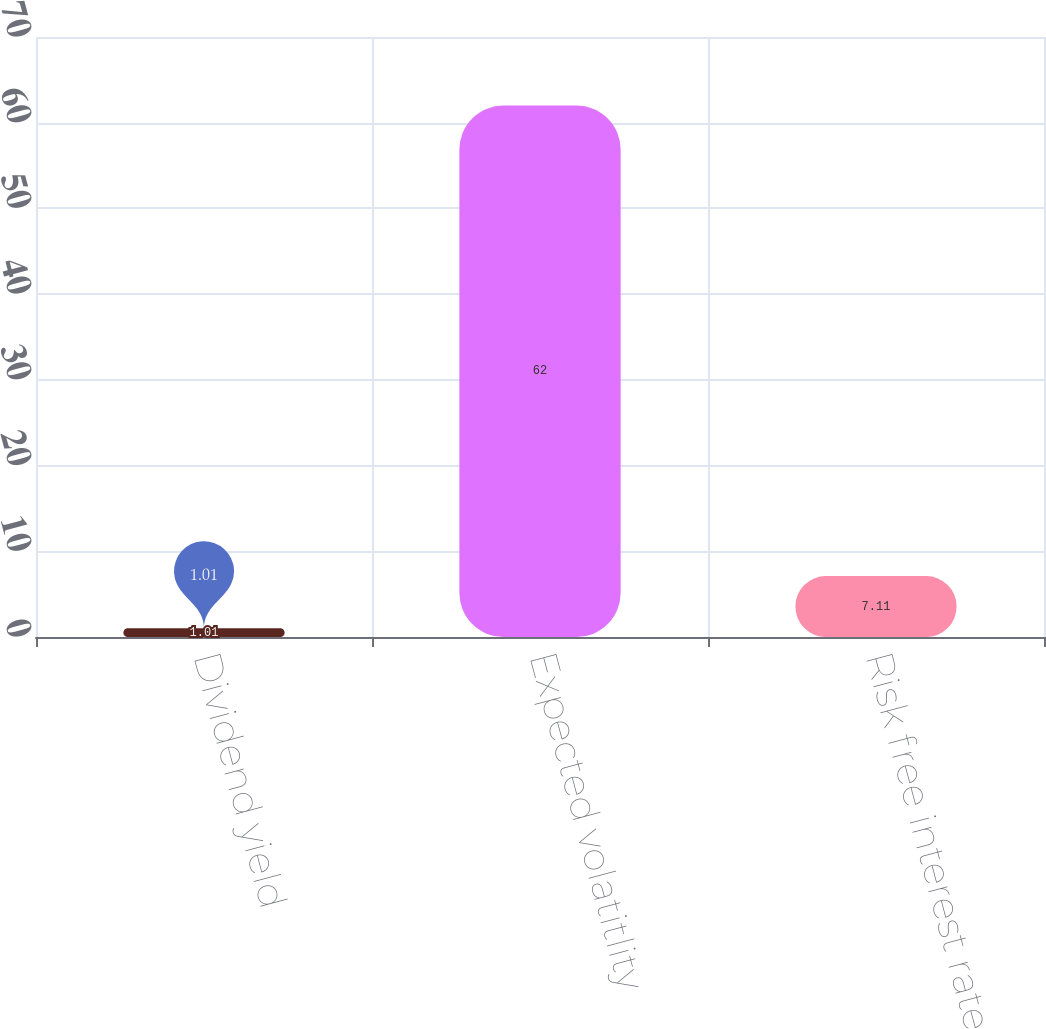Convert chart. <chart><loc_0><loc_0><loc_500><loc_500><bar_chart><fcel>Dividend yield<fcel>Expected volatitlity<fcel>Risk free interest rate<nl><fcel>1.01<fcel>62<fcel>7.11<nl></chart> 